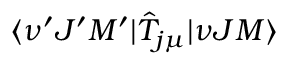<formula> <loc_0><loc_0><loc_500><loc_500>\langle \nu ^ { \prime } J ^ { \prime } M ^ { \prime } | \hat { T } _ { j \mu } | \nu J M \rangle</formula> 